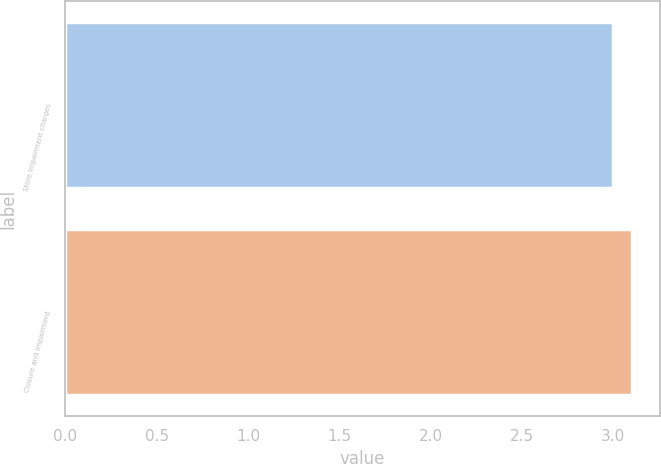<chart> <loc_0><loc_0><loc_500><loc_500><bar_chart><fcel>Store impairment charges<fcel>Closure and impairment<nl><fcel>3<fcel>3.1<nl></chart> 